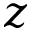Convert formula to latex. <formula><loc_0><loc_0><loc_500><loc_500>z</formula> 